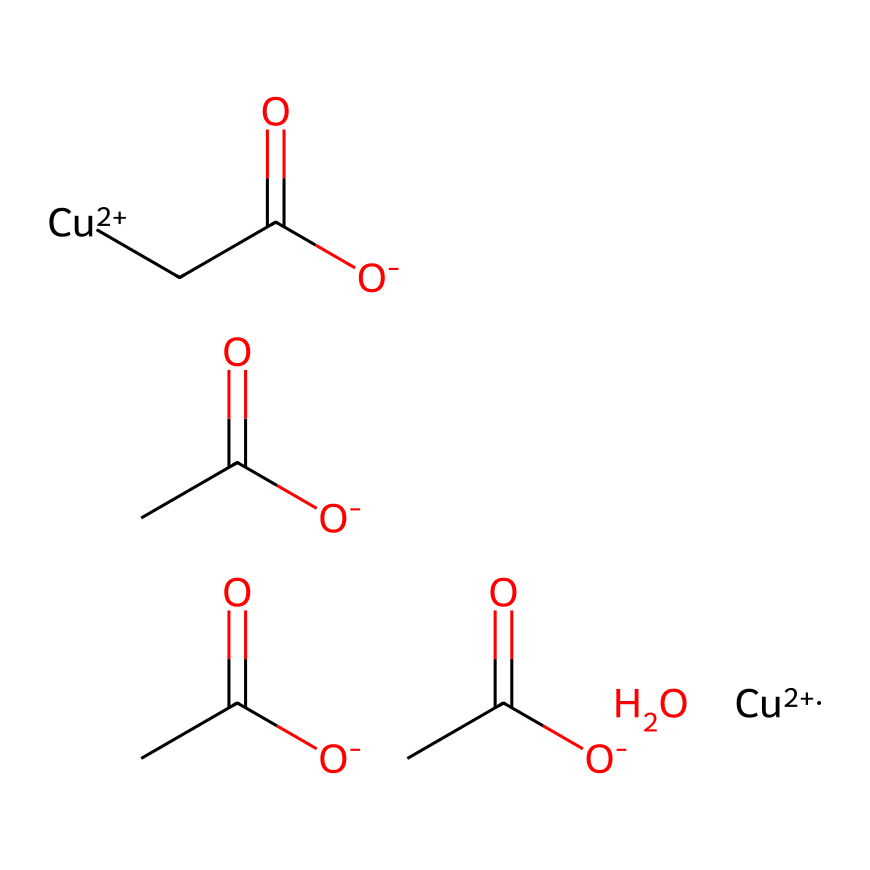How many copper atoms are present in this compound? In the provided SMILES representation, we can identify the copper ions by looking for the notation [Cu+2]. There are two instances of [Cu+2] present, indicating there are two copper atoms.
Answer: two What is the overall charge of this coordination compound? The compound contains two copper ions, each with a charge of +2, and four acetate groups (O-), each with a charge of -1. The total charge calculation is (2 x +2) + (4 x -1) = +4 - 4 = 0, so the overall charge is neutral.
Answer: zero How many acetate (acetic acid) groups are part of this compound? In the SMILES code, we can identify the acetate groups by looking for the notation [O-]C(=O)C, which appears four times in sequence. This means there are four acetate groups in total present in the compound.
Answer: four What type of bonding is primarily responsible for the structure of verdigris? The bonding in verdigris is primarily coordination bonding, which involves the interaction between the copper ions and the lone pairs on the oxygen atoms in the acetate groups, allowing for the formation of a stable complex structure.
Answer: coordination bonding What is the role of copper in the verdigris compound? Copper acts as the central metal ion in the coordination compound of verdigris, facilitating the complexation with acetate ligands and contributing to the pigment's green color through its electronic structure.
Answer: central metal ion How does the presence of acetate groups influence the solubility of this compound? The acetate groups, being negatively charged and polar, increase the solubility of the coordination compound in polar solvents, such as water, due to their ability to interact favorably with solvent molecules.
Answer: increases solubility 